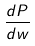<formula> <loc_0><loc_0><loc_500><loc_500>\frac { d P } { d w }</formula> 